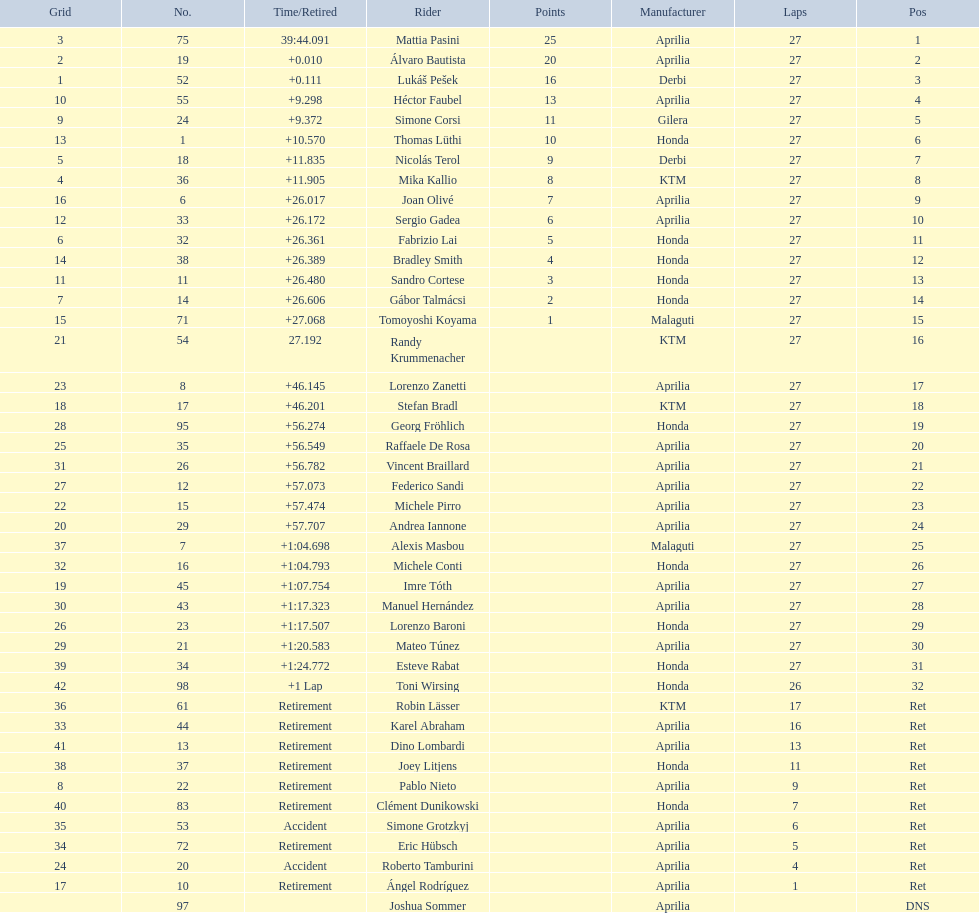How many german racers completed the race? 4. 